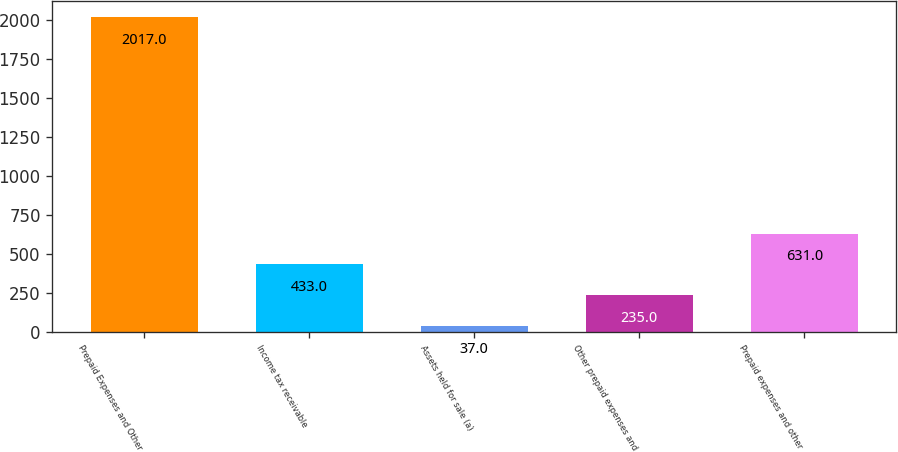<chart> <loc_0><loc_0><loc_500><loc_500><bar_chart><fcel>Prepaid Expenses and Other<fcel>Income tax receivable<fcel>Assets held for sale (a)<fcel>Other prepaid expenses and<fcel>Prepaid expenses and other<nl><fcel>2017<fcel>433<fcel>37<fcel>235<fcel>631<nl></chart> 